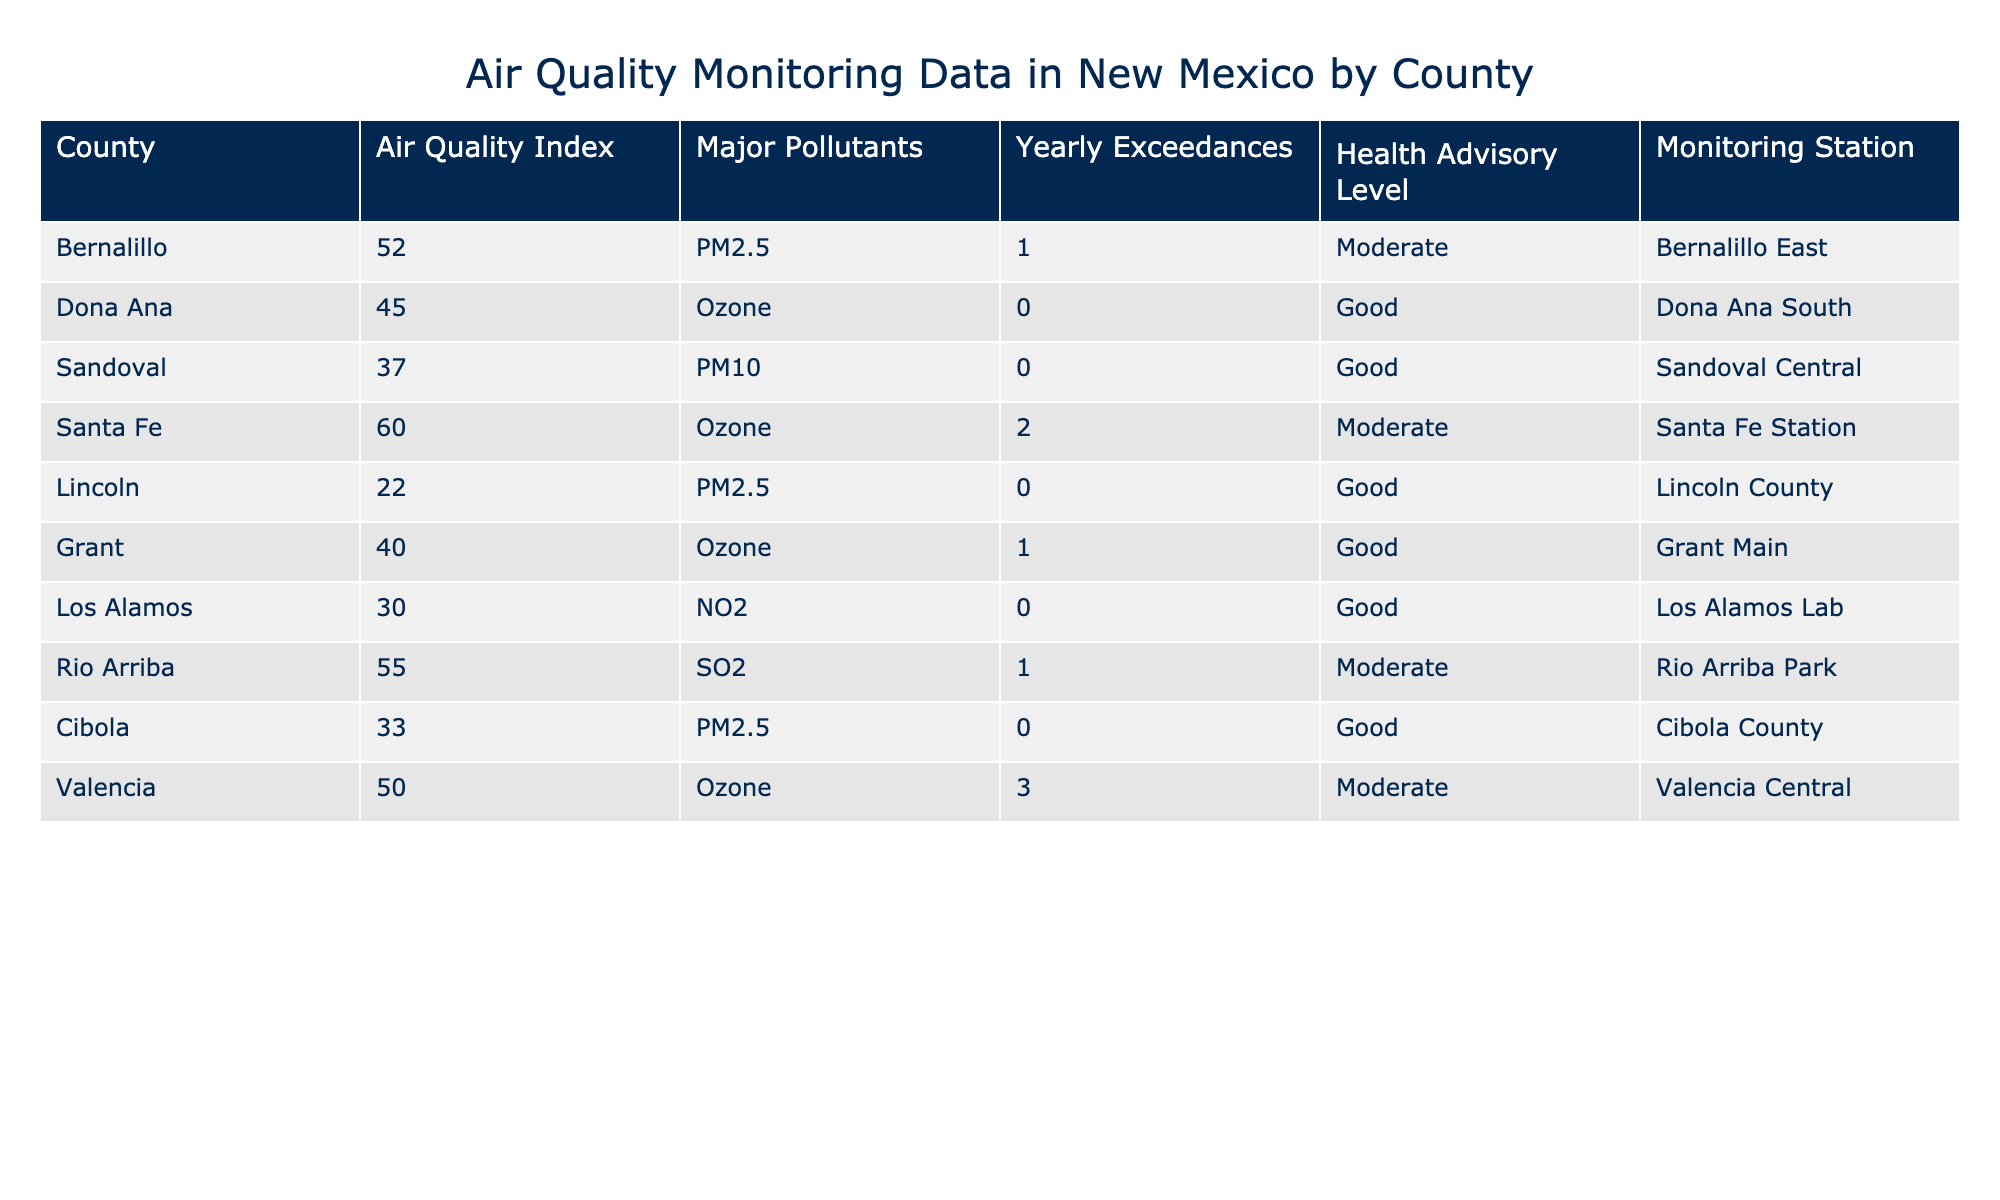What is the Air Quality Index for Valencia County? The Air Quality Index for Valencia County is found in the table under the respective column. By locating the row for Valencia County, I see that its Air Quality Index is 50.
Answer: 50 How many counties have a Health Advisory Level of 'Good'? To find this, I check the Health Advisory Level column and count the counties that have 'Good' listed. The counties with 'Good' status are Dona Ana, Sandoval, Lincoln, Los Alamos, Cibola, and Grant, totaling 6 counties.
Answer: 6 What is the total number of Yearly Exceedances recorded in the table? I sum up the Yearly Exceedances for all counties, which are 1 (Bernalillo) + 0 (Dona Ana) + 0 (Sandoval) + 2 (Santa Fe) + 0 (Lincoln) + 1 (Grant) + 0 (Los Alamos) + 1 (Rio Arriba) + 0 (Cibola) + 3 (Valencia) = 8.
Answer: 8 Is there a county with an Air Quality Index higher than 60? I review the Air Quality Index column and check if any value exceeds 60. The highest Air Quality Index from the table is 60 (Santa Fe), hence there are no counties with an index higher than 60.
Answer: No Which county has the highest Air Quality Index and what is the major pollutant in that county? First, I find the maximum Air Quality Index value in the table, which is 60 (Santa Fe). Then, I refer to the Major Pollutants column to identify that the major pollutant for Santa Fe is Ozone.
Answer: Santa Fe, Ozone What is the average Air Quality Index of the counties that have PM2.5 as a major pollutant? I first find the counties with PM2.5 as the major pollutant, which are Bernalillo and Cibola. Their Air Quality Index values are 52 (Bernalillo) and 33 (Cibola), respectively. I then calculate the average: (52 + 33) / 2 = 42.5.
Answer: 42.5 Are there any counties with more than 2 Yearly Exceedances and what are they? I check the Yearly Exceedances column for values greater than 2. The only county with more than 2 is Valencia, which has 3 exceedances.
Answer: Valencia What proportion of the counties reported PM10 as a major pollutant? I check the Major Pollutants column and only find Sandoval county reporting PM10. Since there are 10 counties in total, the proportion is 1/10 or 10%.
Answer: 10% 